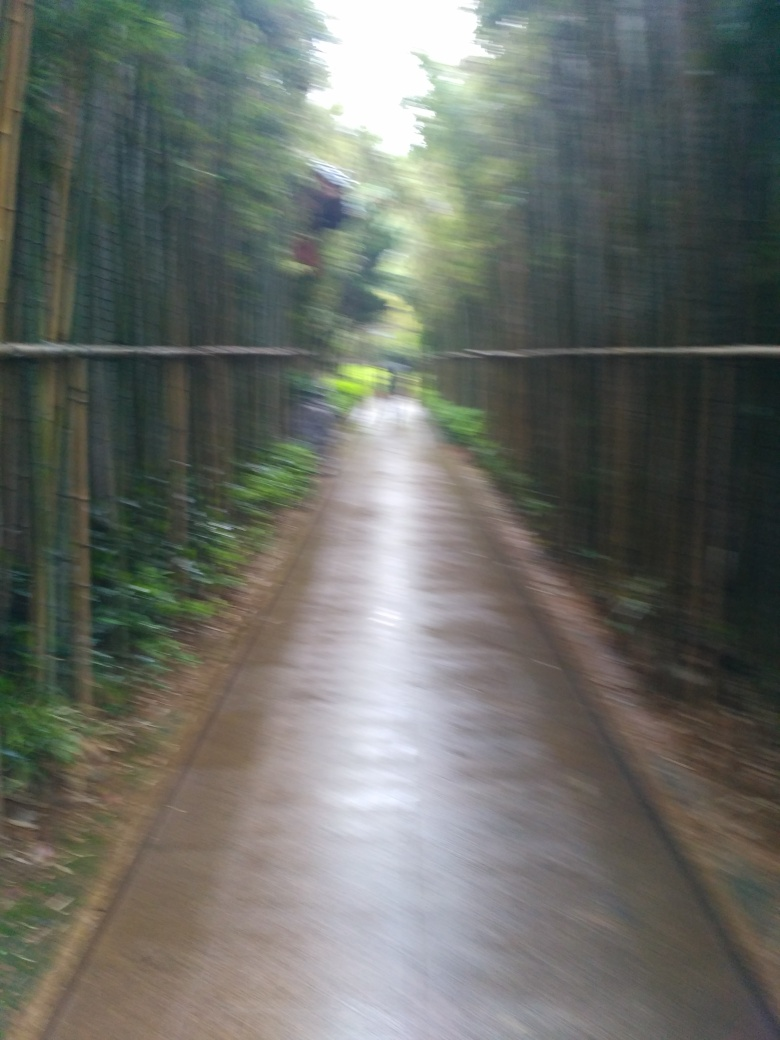Could you suggest what kind of cultural or spiritual significance paths like this one might hold? Paths through bamboo or serene natural settings often hold cultural and spiritual significance, particularly in East Asian contexts. They are seen as spaces of meditation and reflection, symbolizing life's journey, inviting tranquility, and a means to connect with nature's beauty and simplicity. 